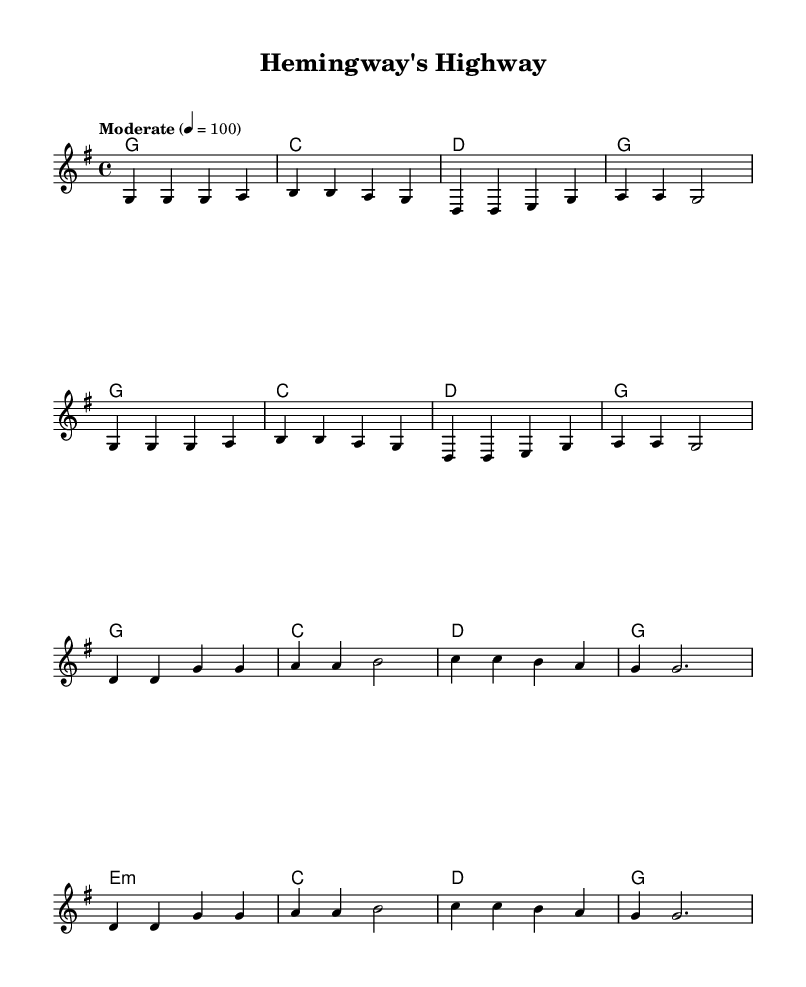What is the key signature of this music? The key signature is G major, which has one sharp (F#).
Answer: G major What is the time signature of the piece? The time signature is 4/4, indicating four beats per measure.
Answer: 4/4 What is the tempo indication for this piece? The tempo is marked as "Moderate," with a metronome marking of 100 beats per minute.
Answer: Moderate How many measures are in the verse section? The verse section consists of 8 measures as indicated by the sequence of notes and chord changes.
Answer: 8 measures Which literary figures are referenced in the lyric? The lyrics reference Huck -- le -- ber -- ry dreams and Gats -- by's gol -- den sand, which refer to Mark Twain and F. Scott Fitzgerald, respectively.
Answer: Mark Twain, F. Scott Fitzgerald What is the chord progression of the chorus? The chorus follows a specific repetition of chords: G, C, D, G; G, C, D, G; with an E minor in the middle. The repetition suggests a folk-like structure common to Country music.
Answer: G, C, D, G; E minor What theme is expressed in the chorus lyrics? The chorus conveys a celebration of storytelling through literature, mentioning authors like Dickens and Donne, reflecting a blend of literary appreciation and country pride.
Answer: Literary pride 